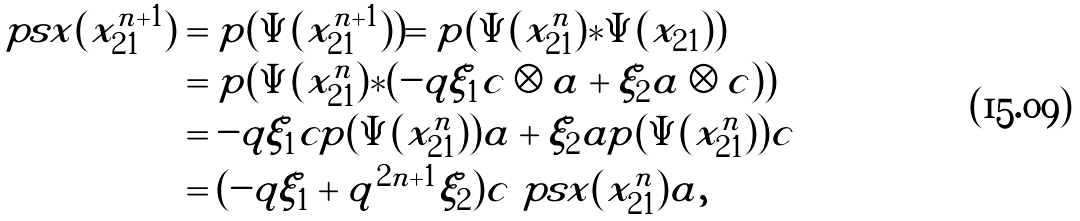<formula> <loc_0><loc_0><loc_500><loc_500>\ p s x ( x _ { 2 1 } ^ { n + 1 } ) & = p ( \Psi ( x _ { 2 1 } ^ { n + 1 } ) ) = p ( \Psi ( x _ { 2 1 } ^ { n } ) * \Psi ( x _ { 2 1 } ) ) \\ & = p ( \Psi ( x _ { 2 1 } ^ { n } ) * ( - q \xi _ { 1 } c \otimes a + \xi _ { 2 } a \otimes c ) ) \\ & = - q \xi _ { 1 } c p ( \Psi ( x _ { 2 1 } ^ { n } ) ) a + \xi _ { 2 } a p ( \Psi ( x _ { 2 1 } ^ { n } ) ) c \\ & = ( - q \xi _ { 1 } + q ^ { 2 n + 1 } \xi _ { 2 } ) c \ p s x ( x _ { 2 1 } ^ { n } ) a ,</formula> 